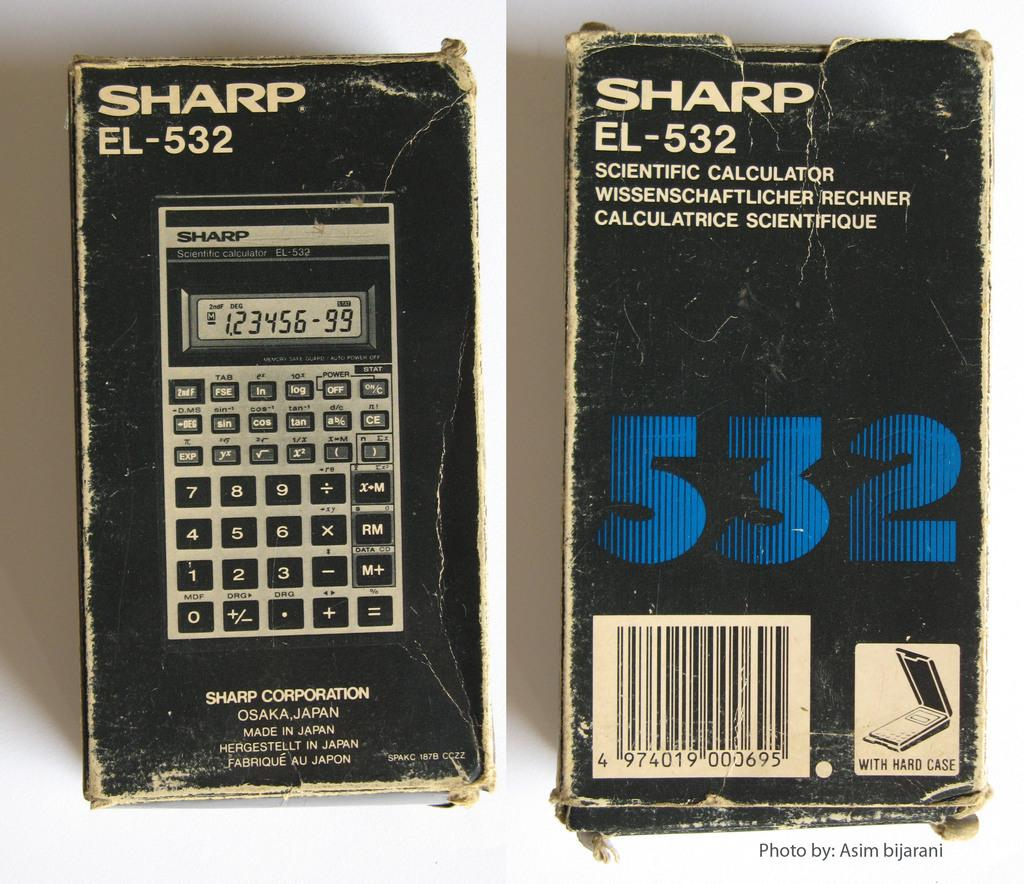<image>
Describe the image concisely. Sharp EL-532 Calculator from the Sharp Corporation, says 123456-99. 